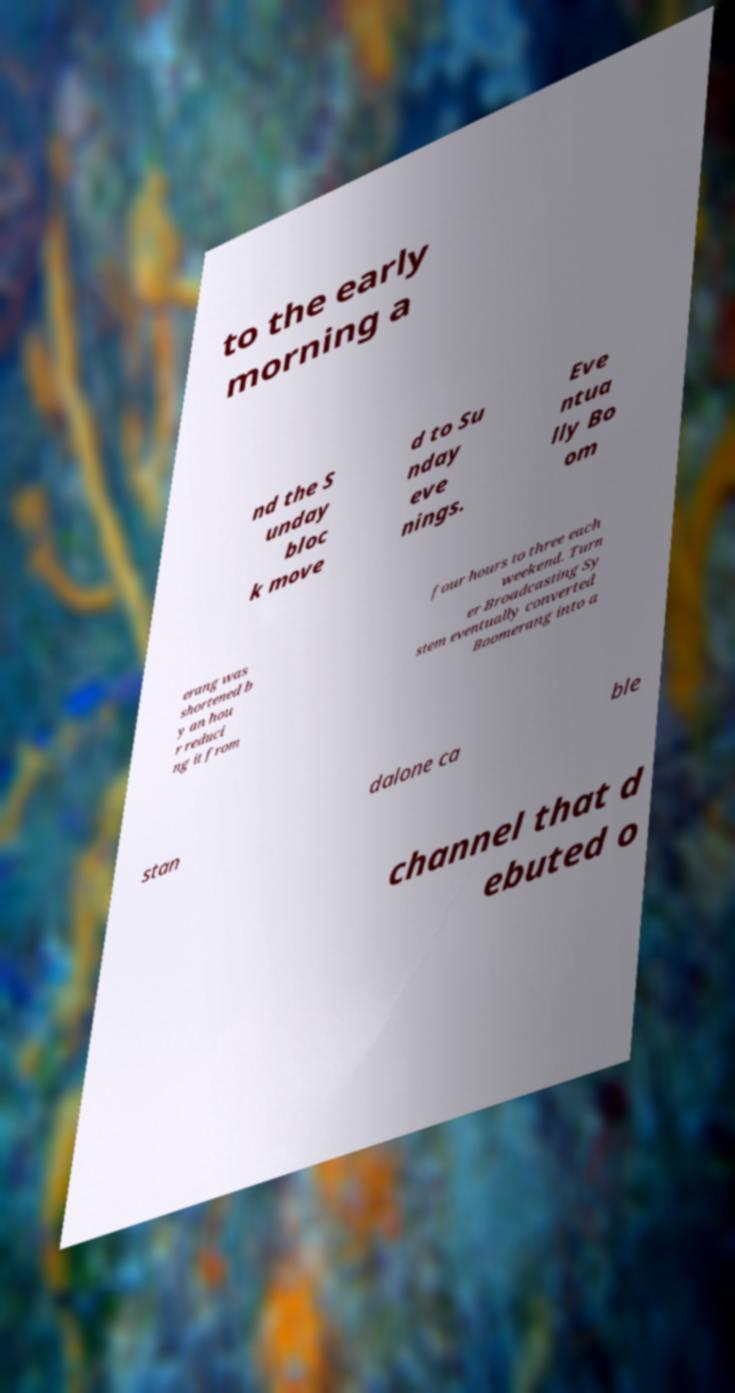Could you assist in decoding the text presented in this image and type it out clearly? to the early morning a nd the S unday bloc k move d to Su nday eve nings. Eve ntua lly Bo om erang was shortened b y an hou r reduci ng it from four hours to three each weekend. Turn er Broadcasting Sy stem eventually converted Boomerang into a stan dalone ca ble channel that d ebuted o 